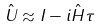<formula> <loc_0><loc_0><loc_500><loc_500>\hat { U } \approx I - i \hat { H } \tau</formula> 